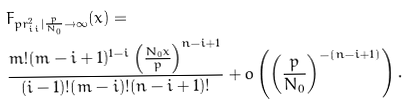<formula> <loc_0><loc_0><loc_500><loc_500>& F _ { p r ^ { 2 } _ { i i } | \frac { p } { N _ { 0 } } \rightarrow \infty } ( x ) = \\ & \frac { m ! ( m - i + 1 ) ^ { 1 - i } \left ( \frac { N _ { 0 } x } { p } \right ) ^ { n - i + 1 } } { ( i - 1 ) ! ( m - i ) ! ( n - i + 1 ) ! } + o \left ( \left ( \frac { p } { N _ { 0 } } \right ) ^ { - ( n - i + 1 ) } \right ) .</formula> 